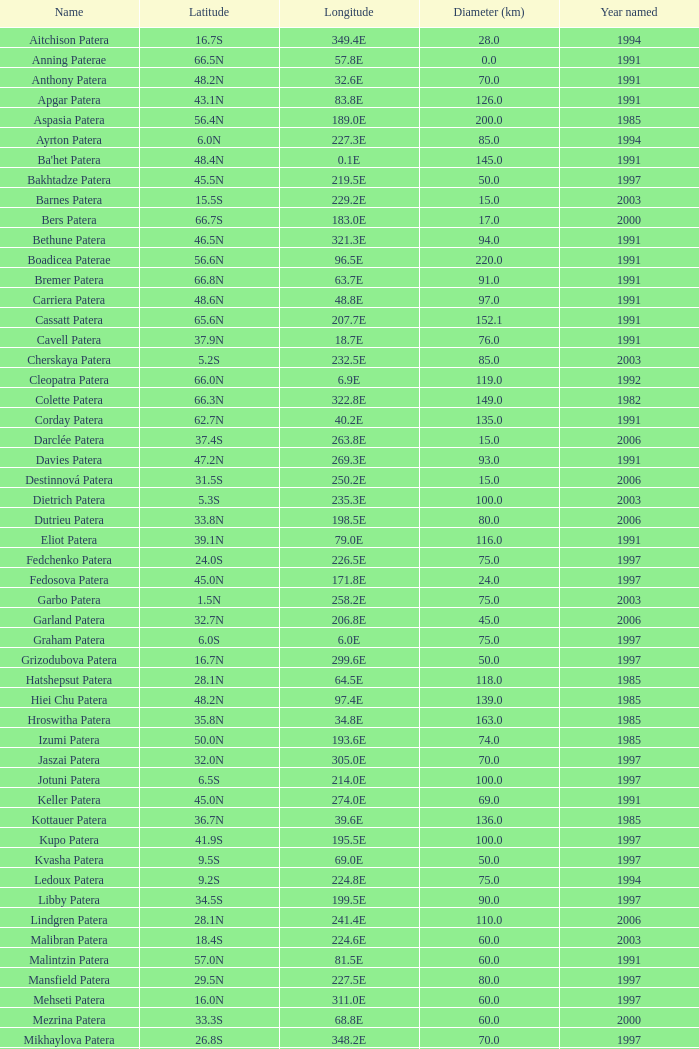At a longitude of 227.5e, what is the corresponding named year? 1997.0. 